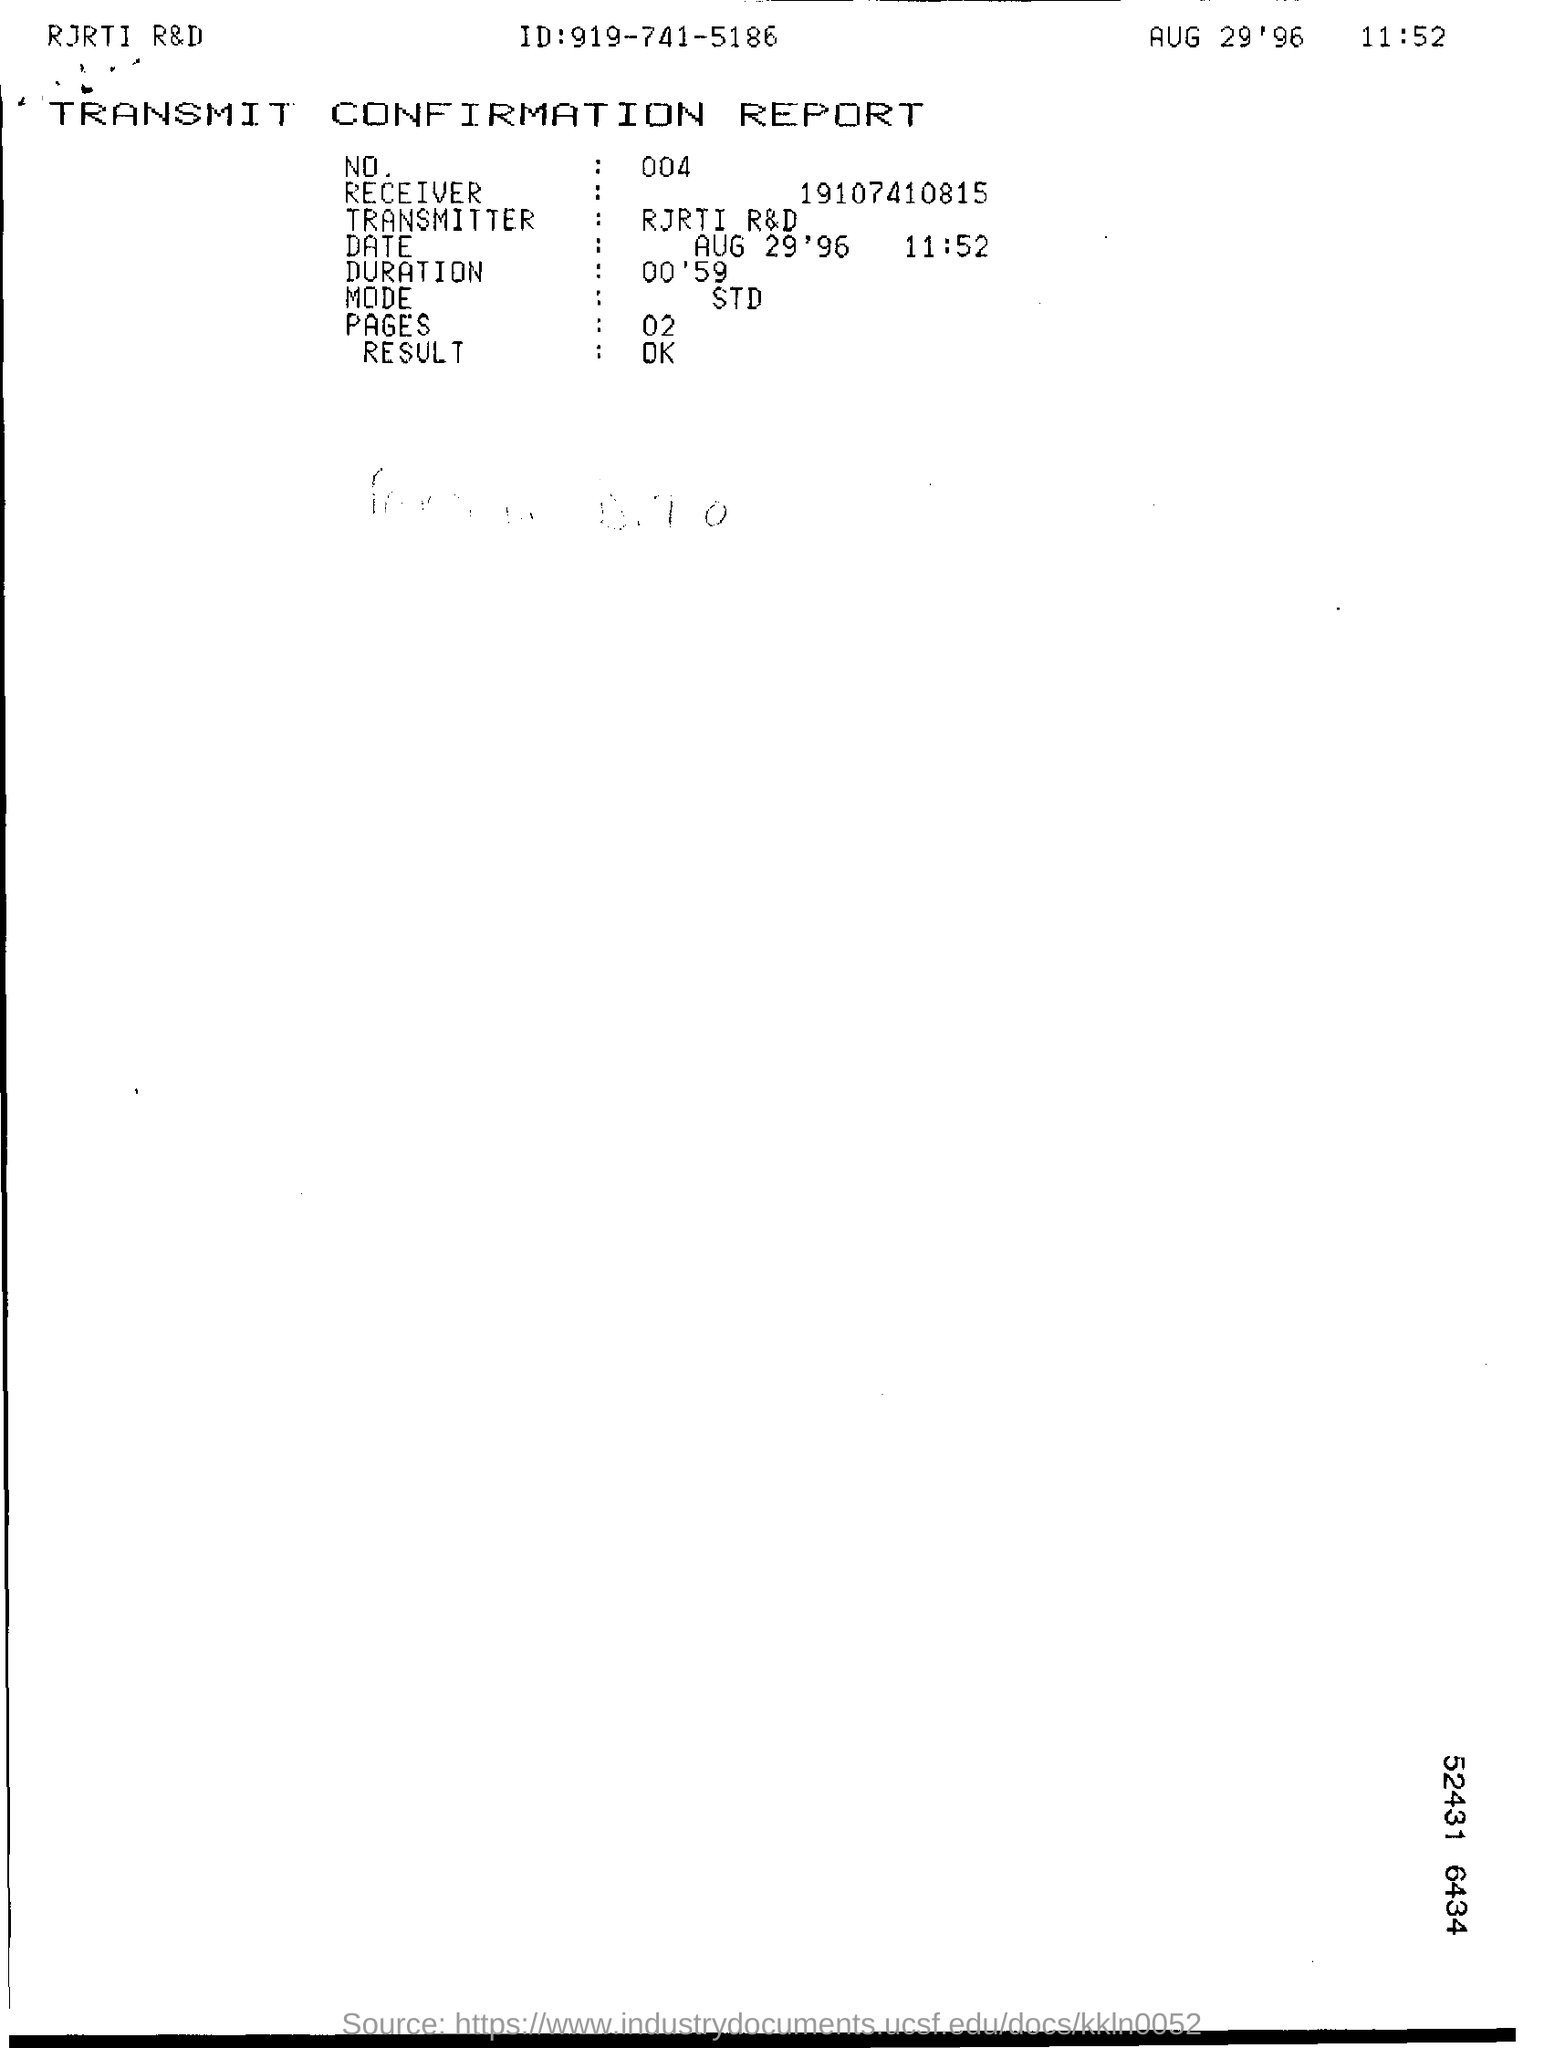Draw attention to some important aspects in this diagram. This is a report that transmits confirmation. 